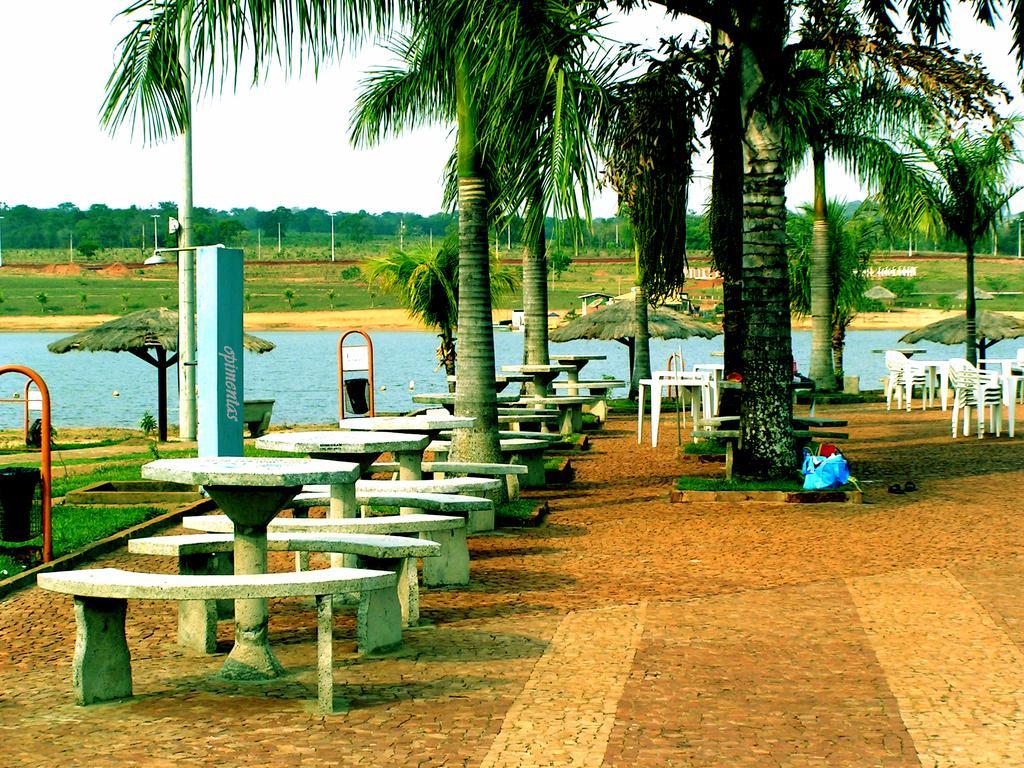Can you describe this image briefly? In this picture there are tables and benches on the left side of the image and there are trees in the center of the image, there are chairs on the right side of the image and there is water in the background area of the image. 